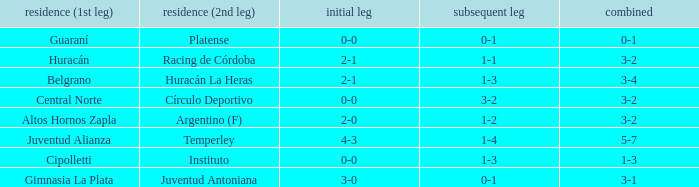What was the aggregate score that had a 1-2 second leg score? 3-2. 